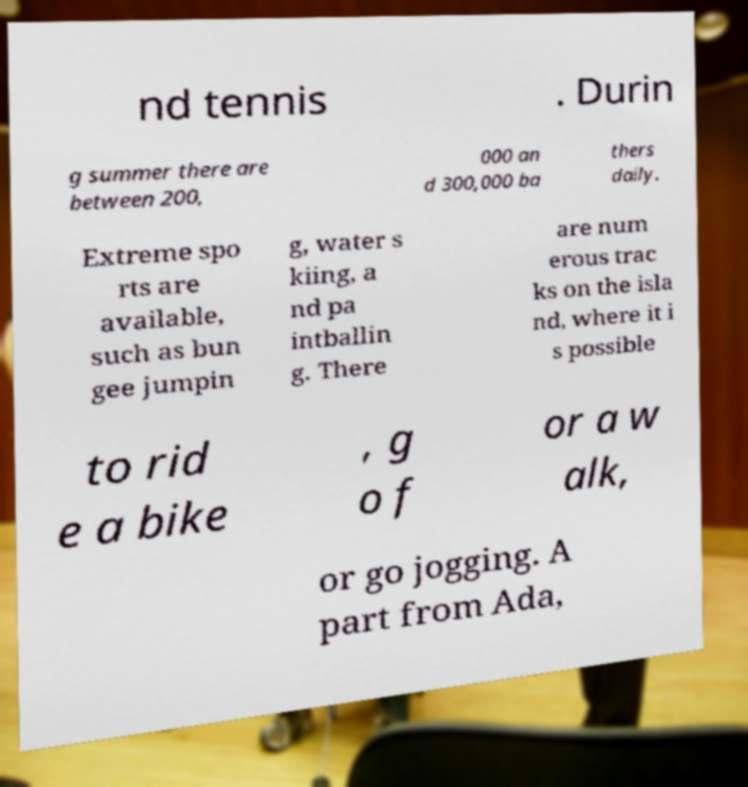Please identify and transcribe the text found in this image. nd tennis . Durin g summer there are between 200, 000 an d 300,000 ba thers daily. Extreme spo rts are available, such as bun gee jumpin g, water s kiing, a nd pa intballin g. There are num erous trac ks on the isla nd, where it i s possible to rid e a bike , g o f or a w alk, or go jogging. A part from Ada, 